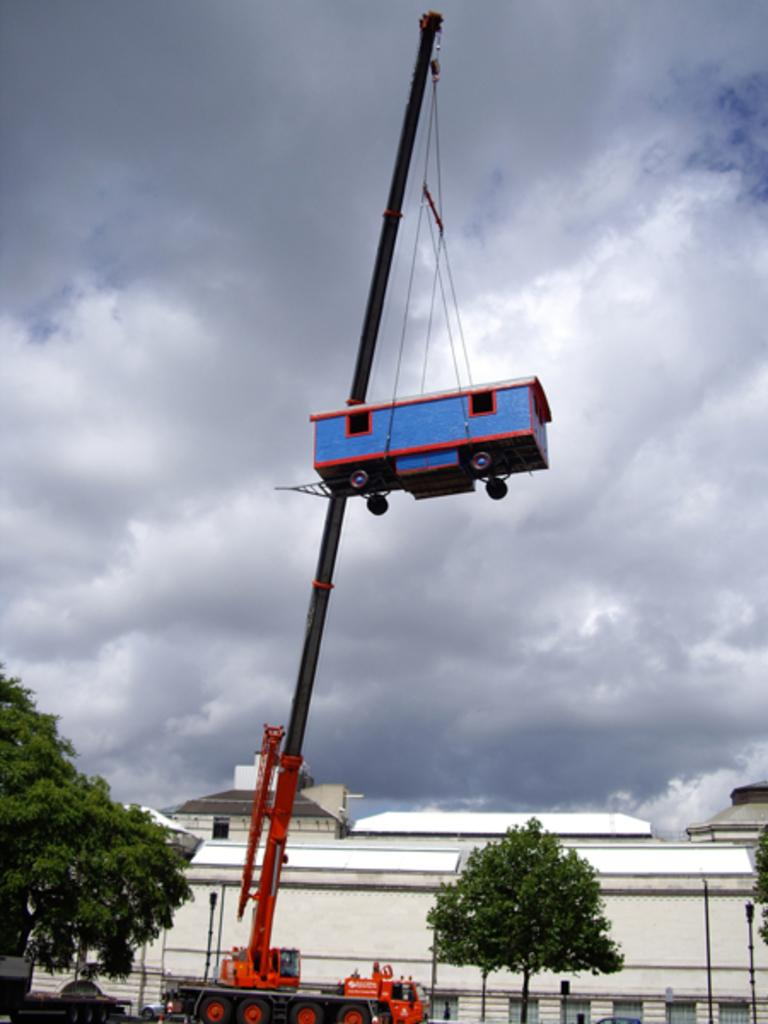What is the main subject of the image? There is a crane in the image. What is the crane doing in the image? The crane is lifting a vehicle. How is the crane lifting the vehicle? The crane is using threads to lift the vehicle. What can be seen in the background of the image? There are trees, poles, buildings, and clouds visible in the image. What type of fan is visible in the image? There is no fan present in the image. What type of work is the crane performing in the image? The image does not specify the type of work the crane is performing, only that it is lifting a vehicle. 